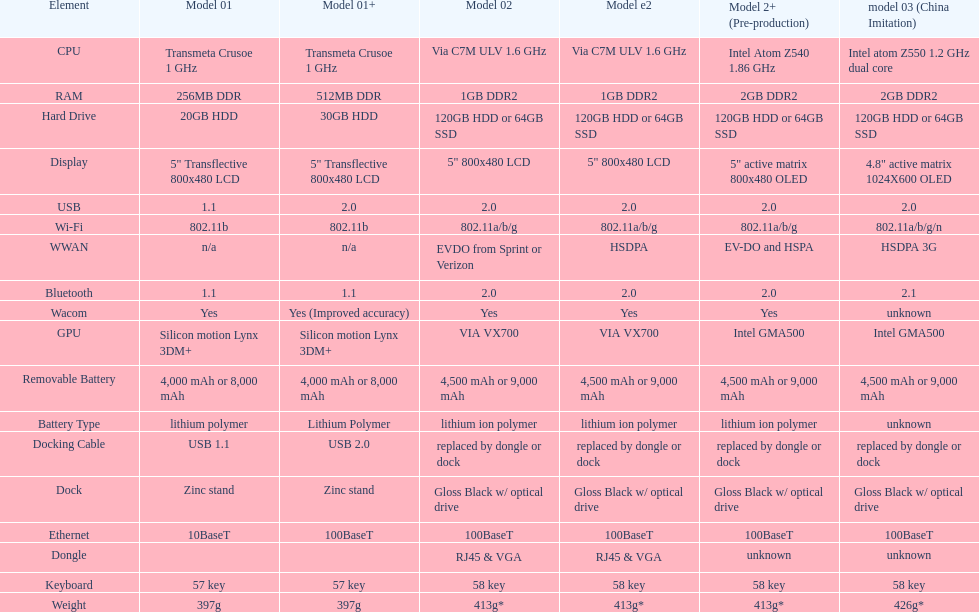How many models have 1.6ghz? 2. 